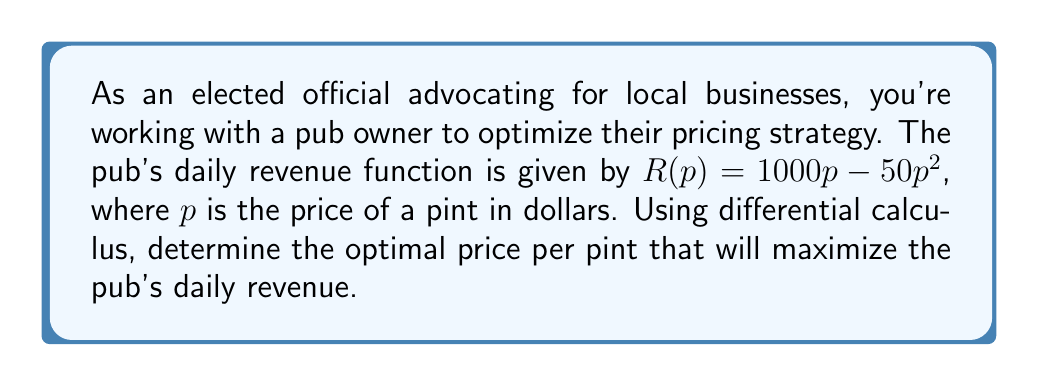Give your solution to this math problem. To find the optimal price that maximizes revenue, we need to follow these steps:

1) The revenue function is given by $R(p) = 1000p - 50p^2$.

2) To find the maximum revenue, we need to find the critical point where the first derivative of R(p) equals zero.

3) Let's calculate the first derivative:
   $$\frac{dR}{dp} = 1000 - 100p$$

4) Set the first derivative equal to zero and solve for p:
   $$1000 - 100p = 0$$
   $$-100p = -1000$$
   $$p = 10$$

5) To confirm this is a maximum (not a minimum), we can check the second derivative:
   $$\frac{d^2R}{dp^2} = -100$$

   Since the second derivative is negative, we confirm that p = 10 gives a maximum.

6) Therefore, the optimal price per pint that maximizes daily revenue is $10.

7) We can calculate the maximum daily revenue by plugging p = 10 into the original revenue function:
   $$R(10) = 1000(10) - 50(10)^2 = 10000 - 5000 = 5000$$

This means the maximum daily revenue is $5000.
Answer: The optimal price per pint that maximizes the pub's daily revenue is $10, resulting in a maximum daily revenue of $5000. 